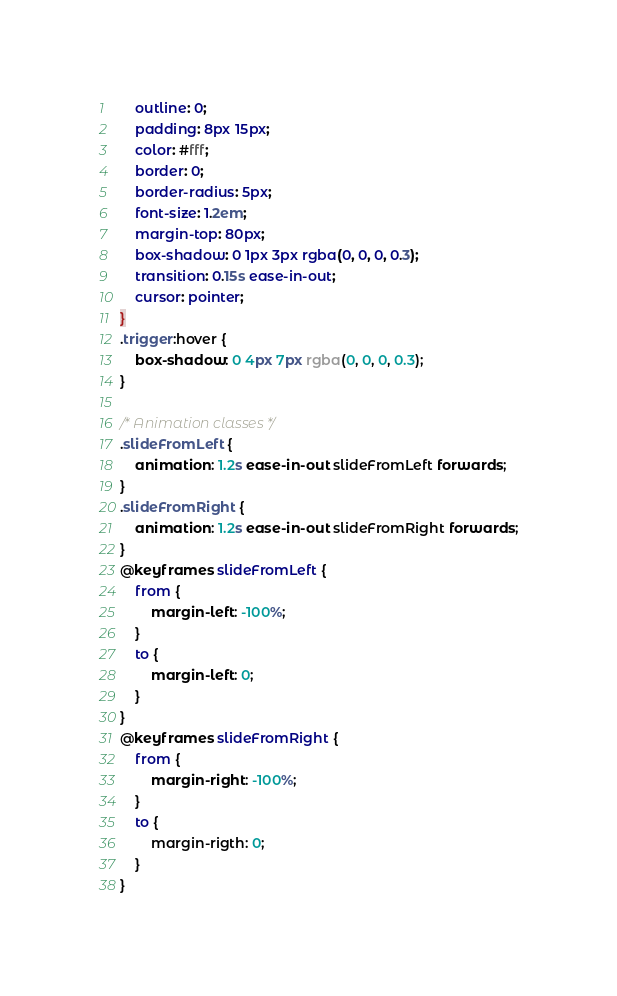<code> <loc_0><loc_0><loc_500><loc_500><_CSS_>	outline: 0;
	padding: 8px 15px;
	color: #fff;
	border: 0;
	border-radius: 5px;
	font-size: 1.2em;
	margin-top: 80px;
	box-shadow: 0 1px 3px rgba(0, 0, 0, 0.3);
	transition: 0.15s ease-in-out;
	cursor: pointer;
}
.trigger:hover {
	box-shadow: 0 4px 7px rgba(0, 0, 0, 0.3);
}

/* Animation classes */
.slideFromLeft {
	animation: 1.2s ease-in-out slideFromLeft forwards;
}
.slideFromRight {
	animation: 1.2s ease-in-out slideFromRight forwards;
}
@keyframes slideFromLeft {
	from {
		margin-left: -100%;
	}
	to {
		margin-left: 0;
	}
}
@keyframes slideFromRight {
	from {
		margin-right: -100%;
	}
	to {
		margin-rigth: 0;
	}
}
</code> 